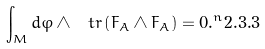Convert formula to latex. <formula><loc_0><loc_0><loc_500><loc_500>\int _ { M } d \varphi \wedge \ t r \left ( F _ { A } \wedge F _ { A } \right ) = 0 . ^ { n } { 2 . 3 . 3 }</formula> 